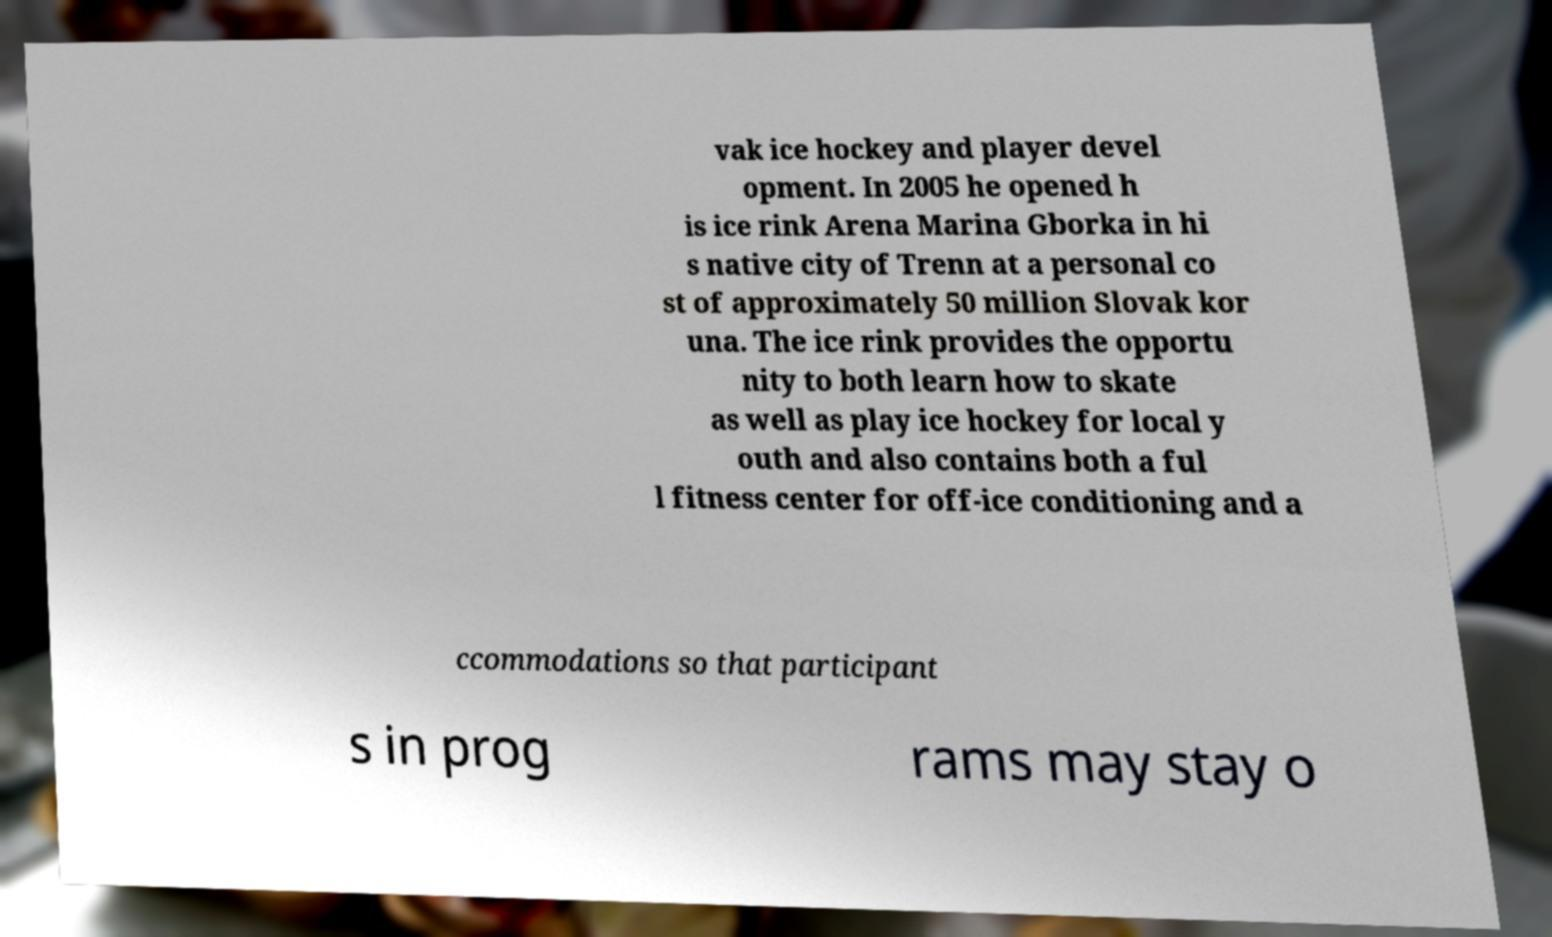Could you extract and type out the text from this image? vak ice hockey and player devel opment. In 2005 he opened h is ice rink Arena Marina Gborka in hi s native city of Trenn at a personal co st of approximately 50 million Slovak kor una. The ice rink provides the opportu nity to both learn how to skate as well as play ice hockey for local y outh and also contains both a ful l fitness center for off-ice conditioning and a ccommodations so that participant s in prog rams may stay o 